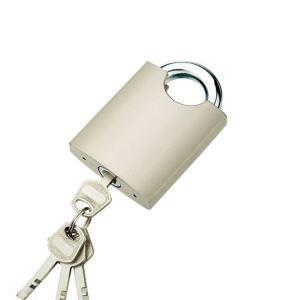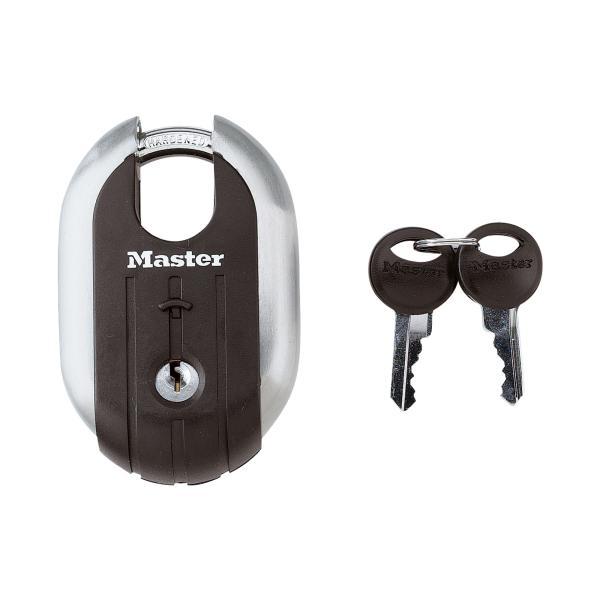The first image is the image on the left, the second image is the image on the right. Considering the images on both sides, is "The left image shows a lock with a key on a keychain inserted." valid? Answer yes or no. Yes. 